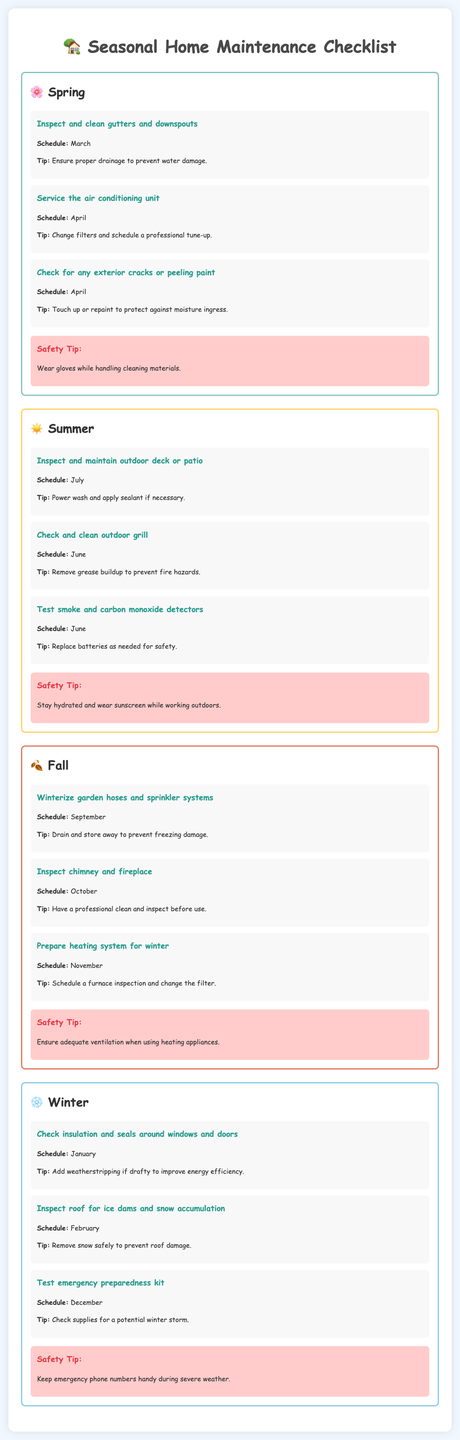What tasks should be done in March? The document lists "Inspect and clean gutters and downspouts" to be done in March under spring tasks.
Answer: Inspect and clean gutters and downspouts What is a safety tip for summer maintenance? The document states that the safety tip for summer is "Stay hydrated and wear sunscreen while working outdoors."
Answer: Stay hydrated and wear sunscreen When should I winterize garden hoses? According to the document, garden hoses should be winterized in September.
Answer: September How many tasks are listed for the winter season? The document lists three tasks under the winter section.
Answer: Three tasks What is the suggested maintenance for air conditioning? In April, the document recommends that you "Service the air conditioning unit."
Answer: Service the air conditioning unit Which month is indicated for checking chimney and fireplace? The document specifies that the chimney and fireplace should be inspected in October.
Answer: October What task is recommended for November? The document suggests to "Prepare heating system for winter" in November.
Answer: Prepare heating system for winter What is one task to test emergency preparedness during winter? The document indicates to "Test emergency preparedness kit" in December as a winter task.
Answer: Test emergency preparedness kit Which safety tip is provided for fall? The safety tip for fall mentioned in the document is "Ensure adequate ventilation when using heating appliances."
Answer: Ensure adequate ventilation when using heating appliances 